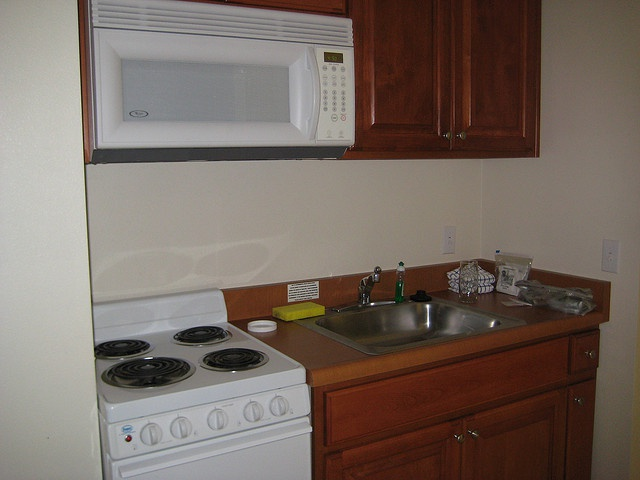Describe the objects in this image and their specific colors. I can see microwave in gray and darkgray tones, oven in gray, darkgray, and black tones, sink in gray and black tones, cup in gray and black tones, and bottle in gray and black tones in this image. 